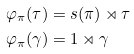<formula> <loc_0><loc_0><loc_500><loc_500>\varphi _ { \pi } ( \tau ) & = s ( \pi ) \rtimes \tau \\ \varphi _ { \pi } ( \gamma ) & = 1 \rtimes \gamma</formula> 